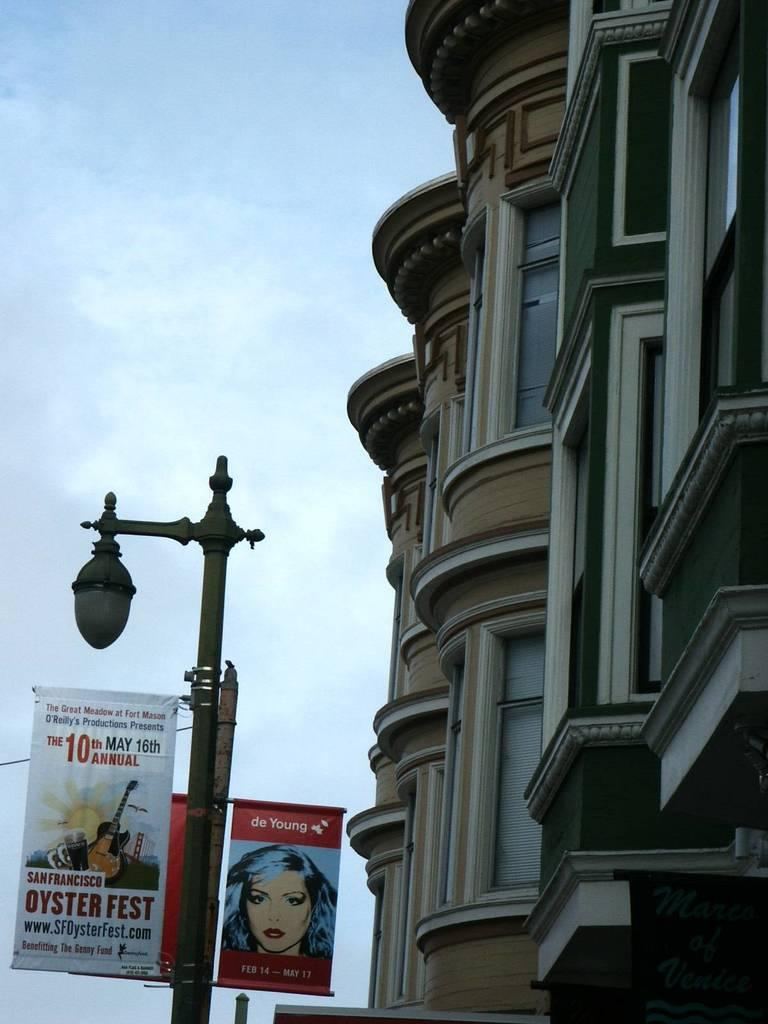What type of structure is visible in the image? There is a building in the image. What is attached to the pole in the image? There is a pole with lights in the image, and advertisement boards are attached to it. What information is displayed on the advertisement boards? The advertisement boards contain text and pictures. How would you describe the sky in the image? The sky is blue and cloudy in the image. Can you hear the bell ringing in the image? There is no bell present in the image, so it cannot be heard. Is there any lettuce growing on the building in the image? There is no lettuce visible in the image; it only features a building, a pole with lights, advertisement boards, and a blue and cloudy sky. 